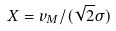<formula> <loc_0><loc_0><loc_500><loc_500>X = v _ { M } / ( \sqrt { 2 } \sigma )</formula> 